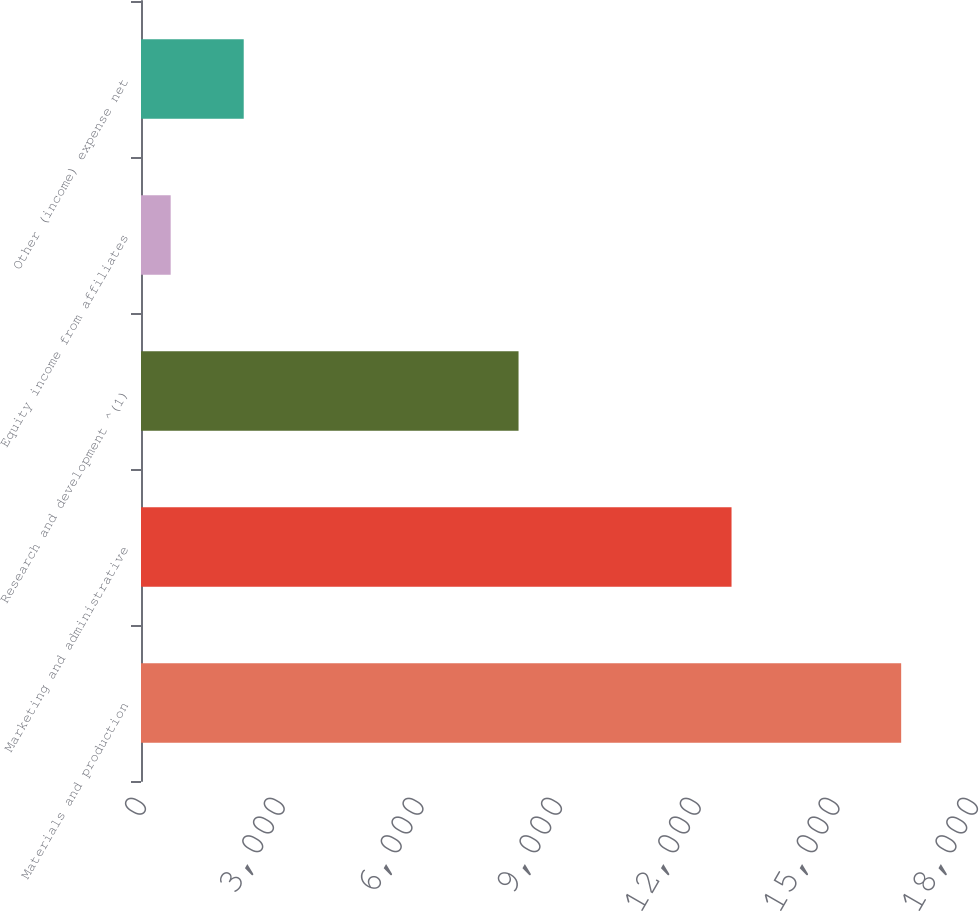<chart> <loc_0><loc_0><loc_500><loc_500><bar_chart><fcel>Materials and production<fcel>Marketing and administrative<fcel>Research and development ^(1)<fcel>Equity income from affiliates<fcel>Other (income) expense net<nl><fcel>16446<fcel>12776<fcel>8168<fcel>642<fcel>2222.4<nl></chart> 